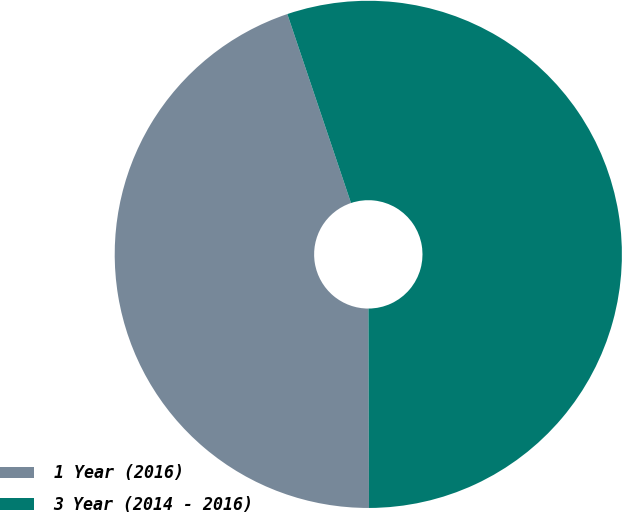Convert chart. <chart><loc_0><loc_0><loc_500><loc_500><pie_chart><fcel>1 Year (2016)<fcel>3 Year (2014 - 2016)<nl><fcel>44.87%<fcel>55.13%<nl></chart> 